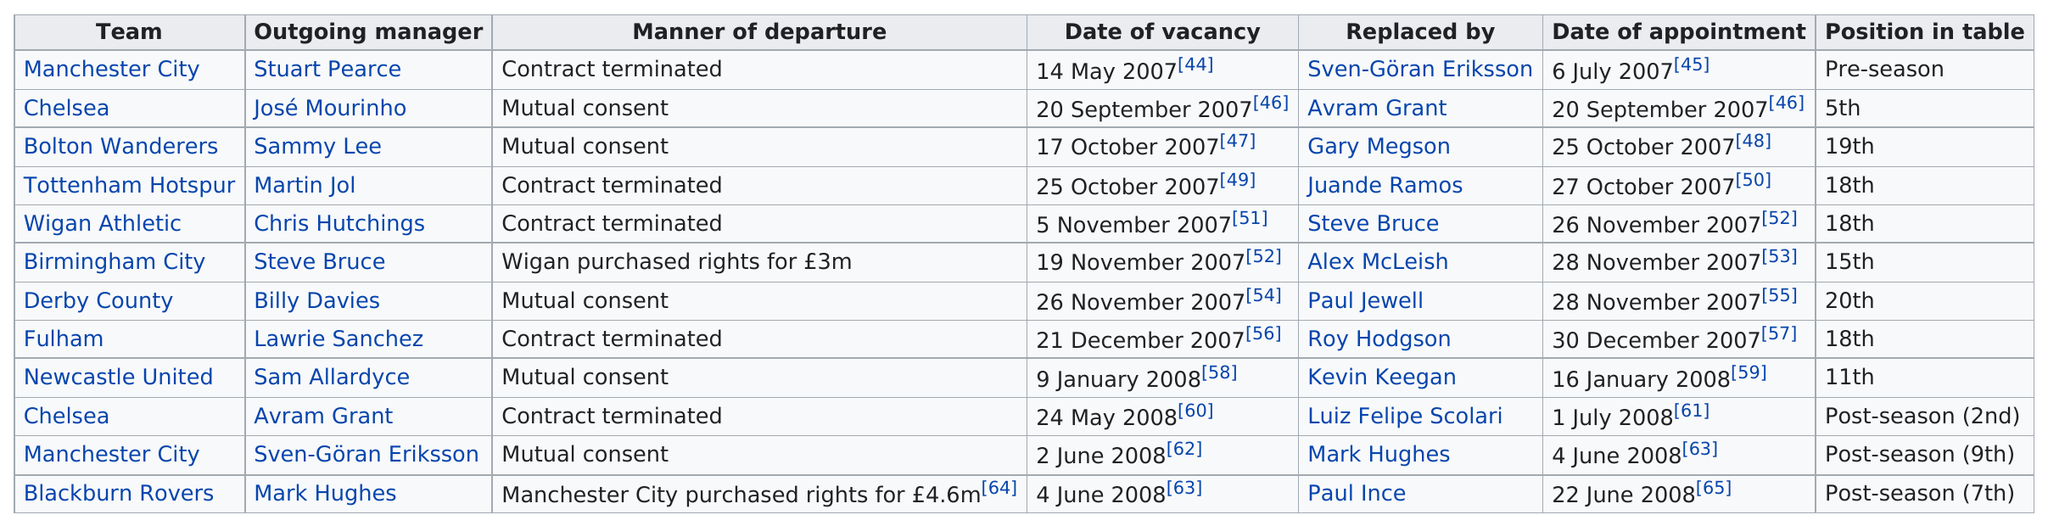Indicate a few pertinent items in this graphic. The most expensive manager in the 2007-08 Premier League season was Mark Hughes, who was purchased for a significant sum of money. Avram Grant was with Chelsea for at least 1 year. Manchester City is followed by Chelsea in a list of football teams. The team that was the only one to place fifth is called Chelsea. Jose Mourinho and Avram Grant were both coaches who were associated with Chelsea. 